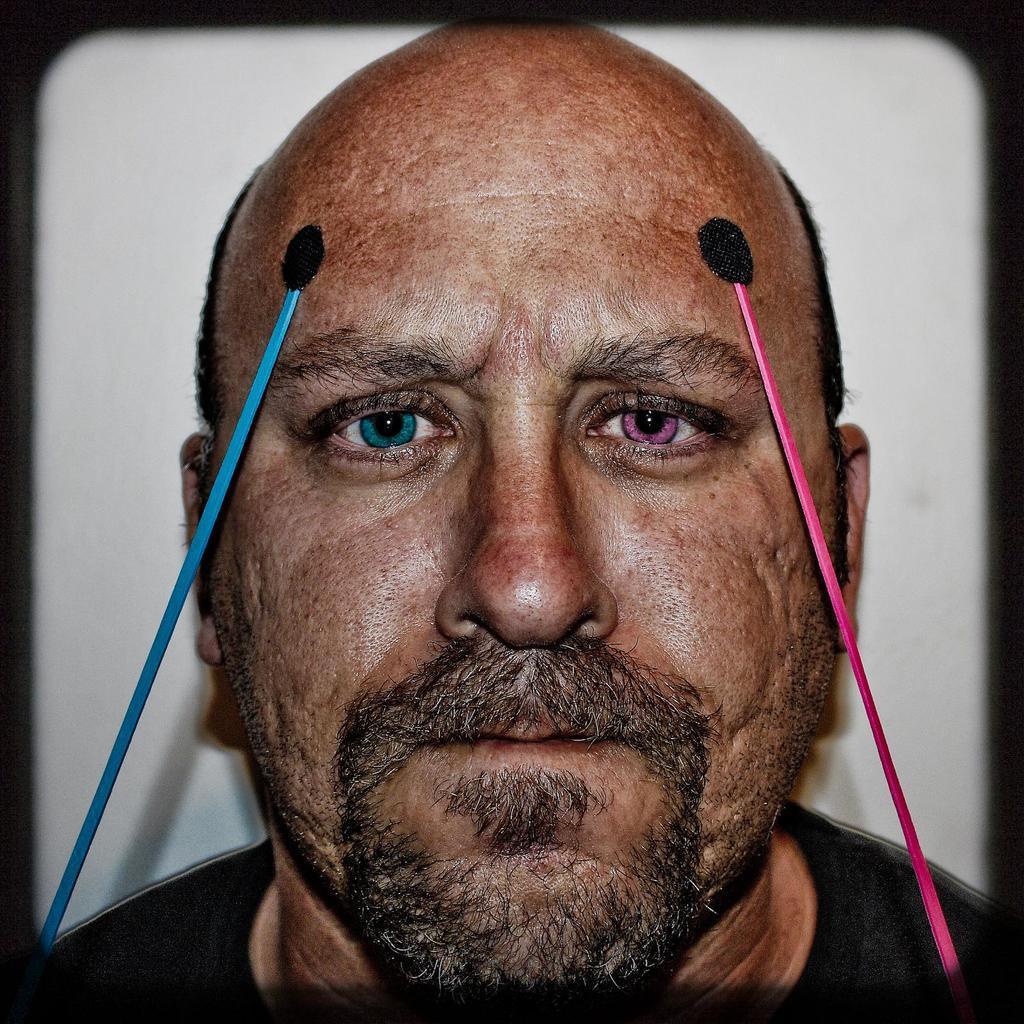Could you give a brief overview of what you see in this image? In this picture, we see a man in black T-shirt is looking at the camera. His left eyeball is in blue color and we see a blue color strip on his head. His right eye is in pink color and we see a pink color strip on his head. In the background, it is white in color. 